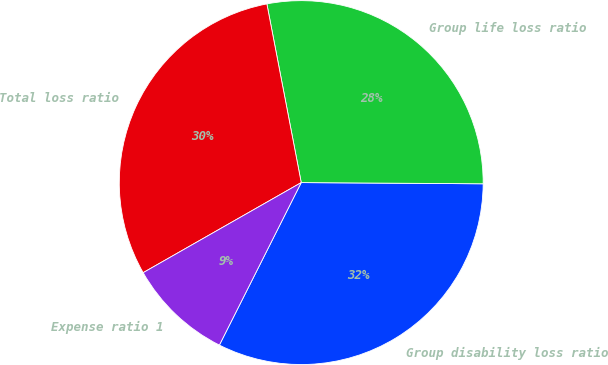<chart> <loc_0><loc_0><loc_500><loc_500><pie_chart><fcel>Group disability loss ratio<fcel>Group life loss ratio<fcel>Total loss ratio<fcel>Expense ratio 1<nl><fcel>32.32%<fcel>28.13%<fcel>30.22%<fcel>9.33%<nl></chart> 